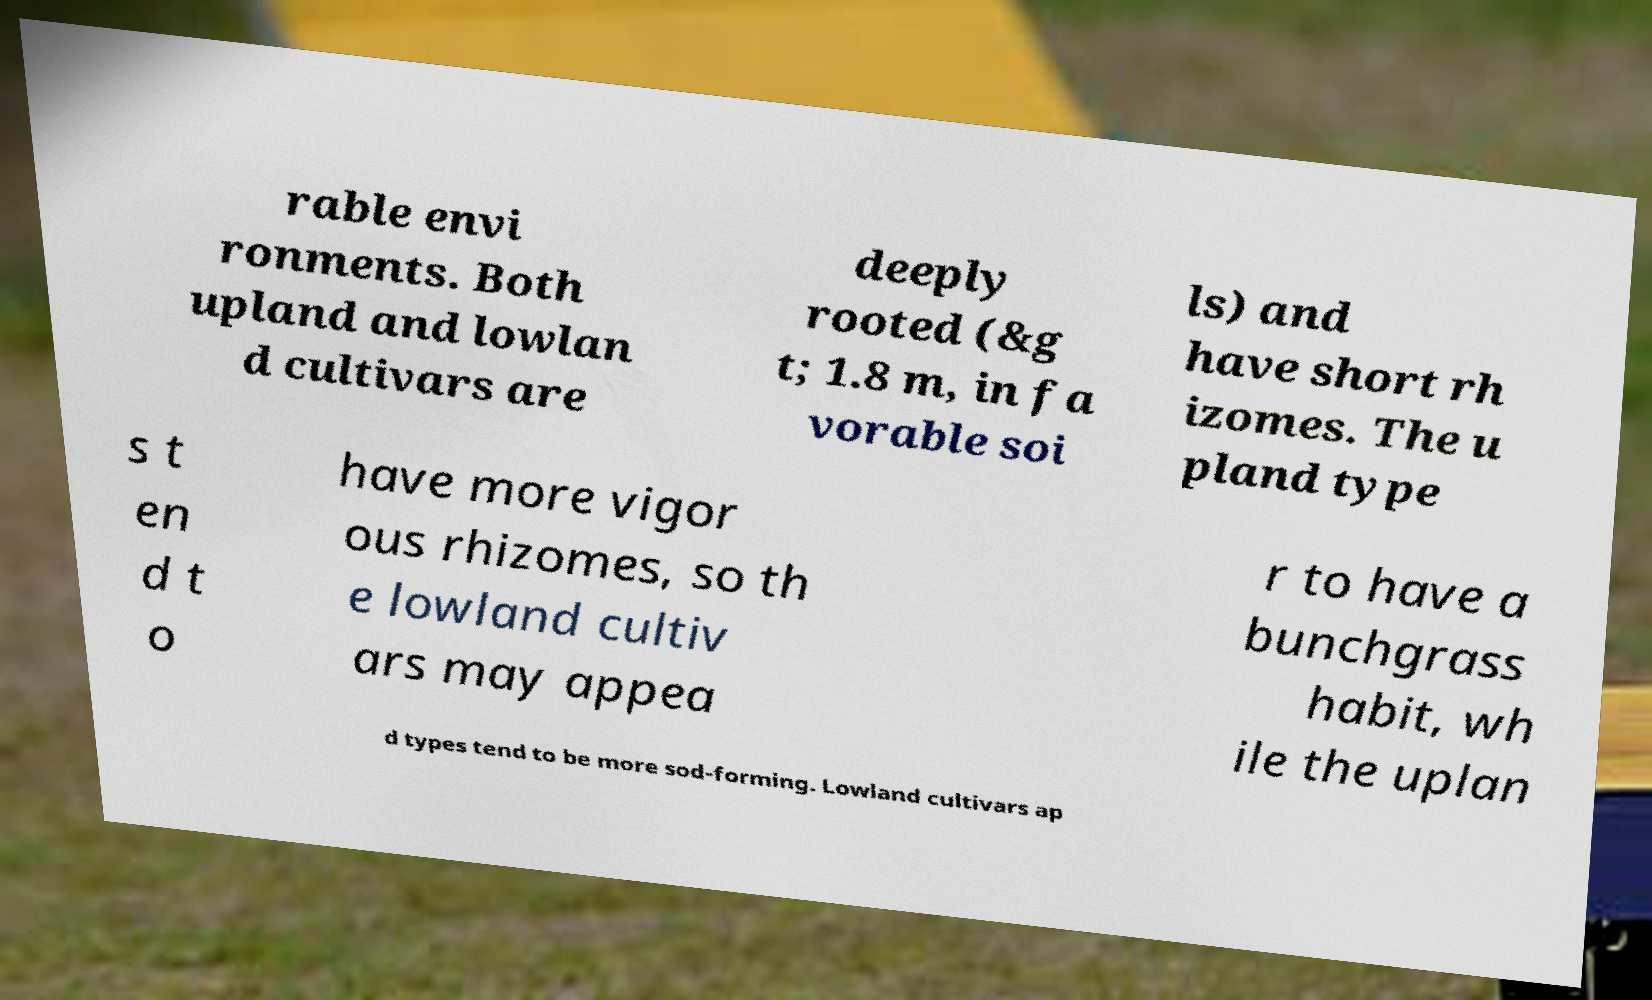Can you read and provide the text displayed in the image?This photo seems to have some interesting text. Can you extract and type it out for me? rable envi ronments. Both upland and lowlan d cultivars are deeply rooted (&g t; 1.8 m, in fa vorable soi ls) and have short rh izomes. The u pland type s t en d t o have more vigor ous rhizomes, so th e lowland cultiv ars may appea r to have a bunchgrass habit, wh ile the uplan d types tend to be more sod-forming. Lowland cultivars ap 